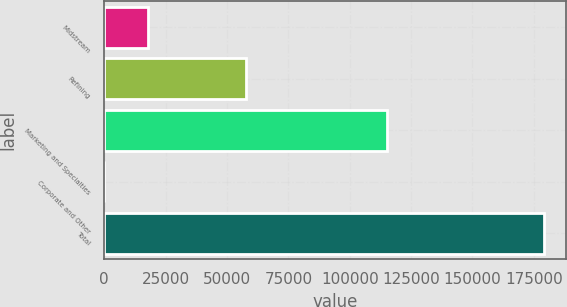Convert chart to OTSL. <chart><loc_0><loc_0><loc_500><loc_500><bar_chart><fcel>Midstream<fcel>Refining<fcel>Marketing and Specialties<fcel>Corporate and Other<fcel>Total<nl><fcel>17940.7<fcel>57761<fcel>115268<fcel>13<fcel>179290<nl></chart> 